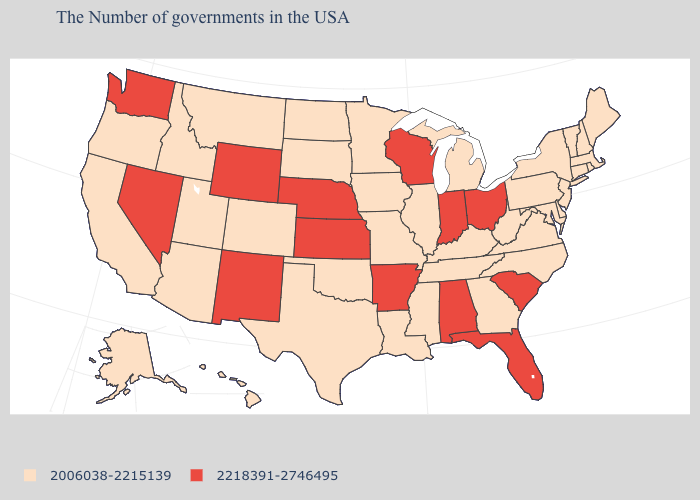What is the lowest value in states that border Mississippi?
Concise answer only. 2006038-2215139. Does the first symbol in the legend represent the smallest category?
Quick response, please. Yes. What is the value of Wyoming?
Write a very short answer. 2218391-2746495. What is the value of Montana?
Be succinct. 2006038-2215139. Which states hav the highest value in the West?
Keep it brief. Wyoming, New Mexico, Nevada, Washington. How many symbols are there in the legend?
Be succinct. 2. Among the states that border Indiana , which have the lowest value?
Concise answer only. Michigan, Kentucky, Illinois. What is the highest value in the West ?
Write a very short answer. 2218391-2746495. Does Illinois have the same value as Maryland?
Short answer required. Yes. What is the value of Vermont?
Answer briefly. 2006038-2215139. Name the states that have a value in the range 2006038-2215139?
Be succinct. Maine, Massachusetts, Rhode Island, New Hampshire, Vermont, Connecticut, New York, New Jersey, Delaware, Maryland, Pennsylvania, Virginia, North Carolina, West Virginia, Georgia, Michigan, Kentucky, Tennessee, Illinois, Mississippi, Louisiana, Missouri, Minnesota, Iowa, Oklahoma, Texas, South Dakota, North Dakota, Colorado, Utah, Montana, Arizona, Idaho, California, Oregon, Alaska, Hawaii. Does Idaho have a lower value than Vermont?
Write a very short answer. No. Does New Mexico have a higher value than Wisconsin?
Quick response, please. No. Name the states that have a value in the range 2006038-2215139?
Write a very short answer. Maine, Massachusetts, Rhode Island, New Hampshire, Vermont, Connecticut, New York, New Jersey, Delaware, Maryland, Pennsylvania, Virginia, North Carolina, West Virginia, Georgia, Michigan, Kentucky, Tennessee, Illinois, Mississippi, Louisiana, Missouri, Minnesota, Iowa, Oklahoma, Texas, South Dakota, North Dakota, Colorado, Utah, Montana, Arizona, Idaho, California, Oregon, Alaska, Hawaii. Which states have the highest value in the USA?
Quick response, please. South Carolina, Ohio, Florida, Indiana, Alabama, Wisconsin, Arkansas, Kansas, Nebraska, Wyoming, New Mexico, Nevada, Washington. 